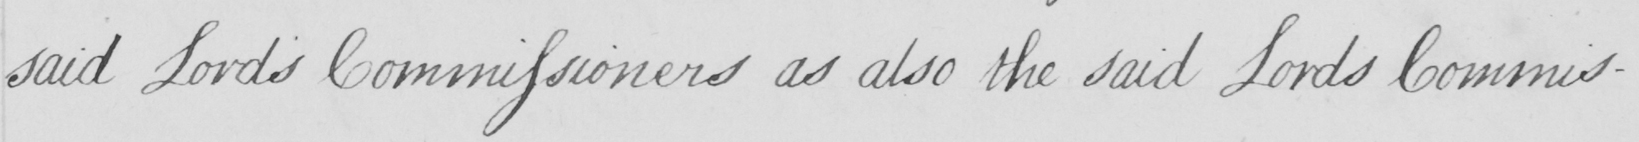Transcribe the text shown in this historical manuscript line. said Lords Commissioners as also the said Lord Commis- 